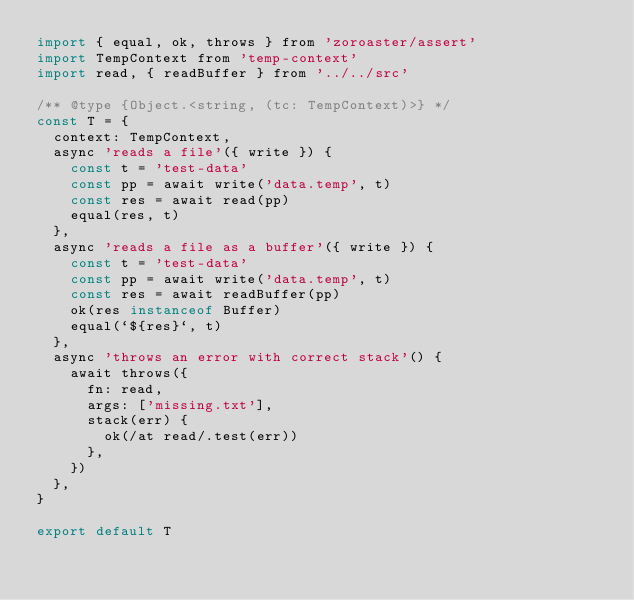<code> <loc_0><loc_0><loc_500><loc_500><_JavaScript_>import { equal, ok, throws } from 'zoroaster/assert'
import TempContext from 'temp-context'
import read, { readBuffer } from '../../src'

/** @type {Object.<string, (tc: TempContext)>} */
const T = {
  context: TempContext,
  async 'reads a file'({ write }) {
    const t = 'test-data'
    const pp = await write('data.temp', t)
    const res = await read(pp)
    equal(res, t)
  },
  async 'reads a file as a buffer'({ write }) {
    const t = 'test-data'
    const pp = await write('data.temp', t)
    const res = await readBuffer(pp)
    ok(res instanceof Buffer)
    equal(`${res}`, t)
  },
  async 'throws an error with correct stack'() {
    await throws({
      fn: read,
      args: ['missing.txt'],
      stack(err) {
        ok(/at read/.test(err))
      },
    })
  },
}

export default T</code> 